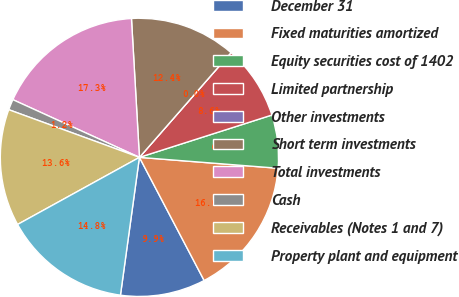<chart> <loc_0><loc_0><loc_500><loc_500><pie_chart><fcel>December 31<fcel>Fixed maturities amortized<fcel>Equity securities cost of 1402<fcel>Limited partnership<fcel>Other investments<fcel>Short term investments<fcel>Total investments<fcel>Cash<fcel>Receivables (Notes 1 and 7)<fcel>Property plant and equipment<nl><fcel>9.88%<fcel>16.05%<fcel>6.17%<fcel>8.64%<fcel>0.0%<fcel>12.35%<fcel>17.28%<fcel>1.24%<fcel>13.58%<fcel>14.81%<nl></chart> 